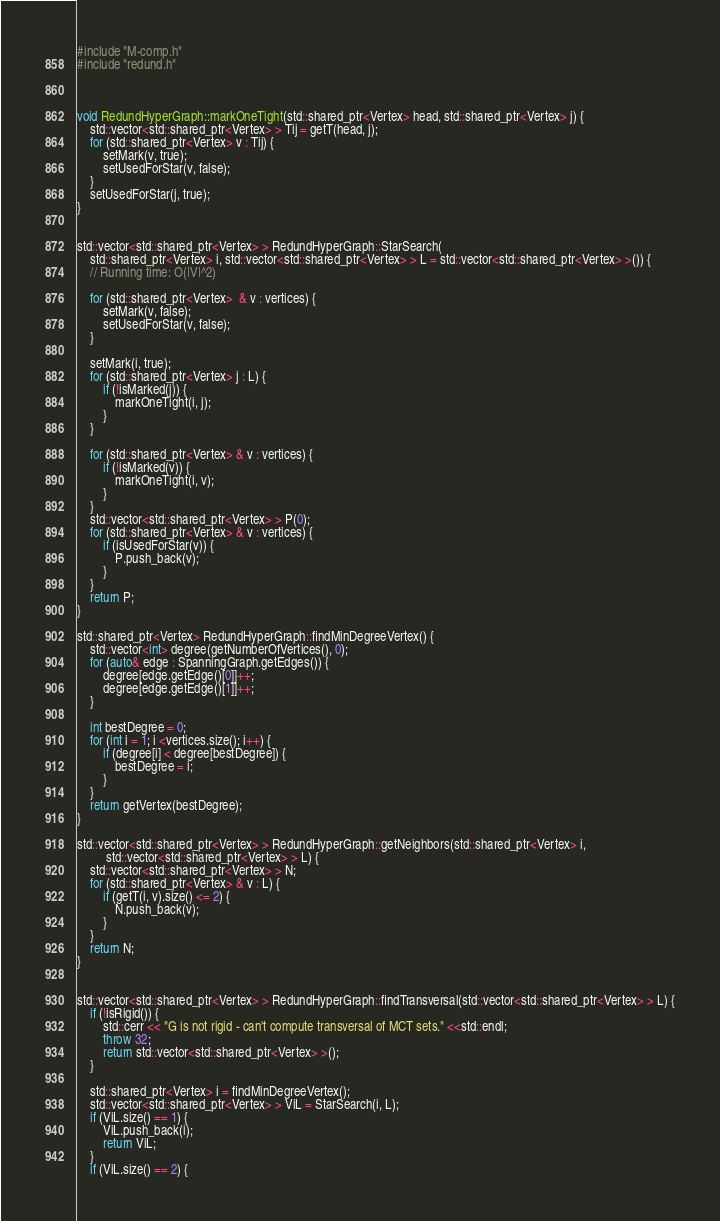Convert code to text. <code><loc_0><loc_0><loc_500><loc_500><_C++_>#include "M-comp.h"
#include "redund.h"



void RedundHyperGraph::markOneTight(std::shared_ptr<Vertex> head, std::shared_ptr<Vertex> j) {
    std::vector<std::shared_ptr<Vertex> > Tij = getT(head, j);
    for (std::shared_ptr<Vertex> v : Tij) {
        setMark(v, true);
        setUsedForStar(v, false);
    }
    setUsedForStar(j, true);
}


std::vector<std::shared_ptr<Vertex> > RedundHyperGraph::StarSearch(
    std::shared_ptr<Vertex> i, std::vector<std::shared_ptr<Vertex> > L = std::vector<std::shared_ptr<Vertex> >()) {
    // Running time: O(|V|^2)

    for (std::shared_ptr<Vertex>  & v : vertices) {
        setMark(v, false);
        setUsedForStar(v, false);
    }

    setMark(i, true);
    for (std::shared_ptr<Vertex> j : L) {
        if (!isMarked(j)) {
            markOneTight(i, j);
        }
    }

    for (std::shared_ptr<Vertex> & v : vertices) {
        if (!isMarked(v)) {
            markOneTight(i, v);
        }
    }
    std::vector<std::shared_ptr<Vertex> > P(0);
    for (std::shared_ptr<Vertex> & v : vertices) {
        if (isUsedForStar(v)) {
            P.push_back(v);
        }
    }
    return P;
}

std::shared_ptr<Vertex> RedundHyperGraph::findMinDegreeVertex() {
    std::vector<int> degree(getNumberOfVertices(), 0);
    for (auto& edge : SpanningGraph.getEdges()) {
        degree[edge.getEdge()[0]]++;
        degree[edge.getEdge()[1]]++;
    }

    int bestDegree = 0;
    for (int i = 1; i <vertices.size(); i++) {
        if (degree[i] < degree[bestDegree]) {
            bestDegree = i;
        }
    }
    return getVertex(bestDegree);
}

std::vector<std::shared_ptr<Vertex> > RedundHyperGraph::getNeighbors(std::shared_ptr<Vertex> i,
         std::vector<std::shared_ptr<Vertex> > L) {
    std::vector<std::shared_ptr<Vertex> > N;
    for (std::shared_ptr<Vertex> & v : L) {
        if (getT(i, v).size() <= 2) {
            N.push_back(v);
        }
    }
    return N;
}


std::vector<std::shared_ptr<Vertex> > RedundHyperGraph::findTransversal(std::vector<std::shared_ptr<Vertex> > L) {
    if (!isRigid()) {
        std::cerr << "G is not rigid - can't compute transversal of MCT sets." <<std::endl;
        throw 32;
        return std::vector<std::shared_ptr<Vertex> >();
    }

    std::shared_ptr<Vertex> i = findMinDegreeVertex();
    std::vector<std::shared_ptr<Vertex> > ViL = StarSearch(i, L);
    if (ViL.size() == 1) {
        ViL.push_back(i);
        return ViL;
    }
    if (ViL.size() == 2) {</code> 